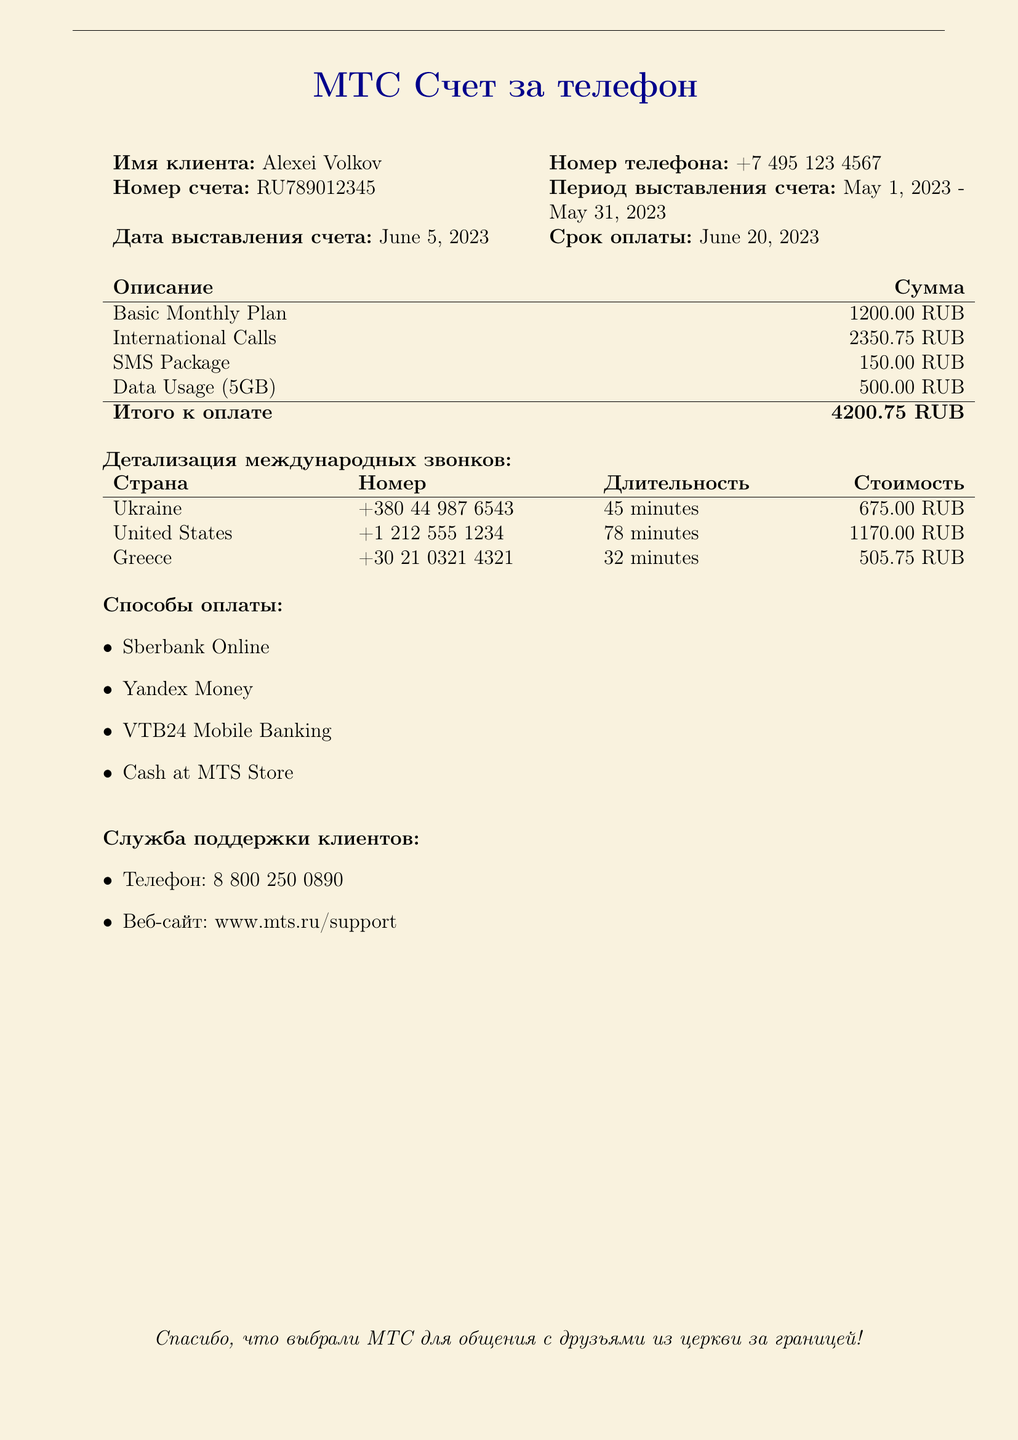какова общая сумма к оплате? Общая сумма к оплате представлена в разделе "Итого к оплате" в документе.
Answer: 4200.75 RUB какова стоимость международных звонков в Украине? Стоимость международных звонков в Украине указана в разделе "Детализация международных звонков".
Answer: 675.00 RUB сколько минут длился звонок в США? Длительность звонка в США указана в таблице "Детализация международных звонков".
Answer: 78 minutes какова дата выставления счета? Дата выставления счета указана в таблице с основными данными о клиенте.
Answer: June 5, 2023 какие способы оплаты указаны в документе? Способы оплаты перечислены в разделе "Способы оплаты".
Answer: Sberbank Online, Yandex Money, VTB24 Mobile Banking, Cash at MTS Store сколько стоит пакет SMS? Цена пакета SMS указана в разделе с описанием услуг и цен.
Answer: 150.00 RUB как называется телефонный оператор? Название телефонного оператора указано в заголовке документа.
Answer: МТС каков срок оплаты? Срок оплаты указан в таблице с основными данными о клиенте.
Answer: June 20, 2023 